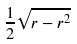<formula> <loc_0><loc_0><loc_500><loc_500>\frac { 1 } { 2 } \sqrt { r - r ^ { 2 } }</formula> 